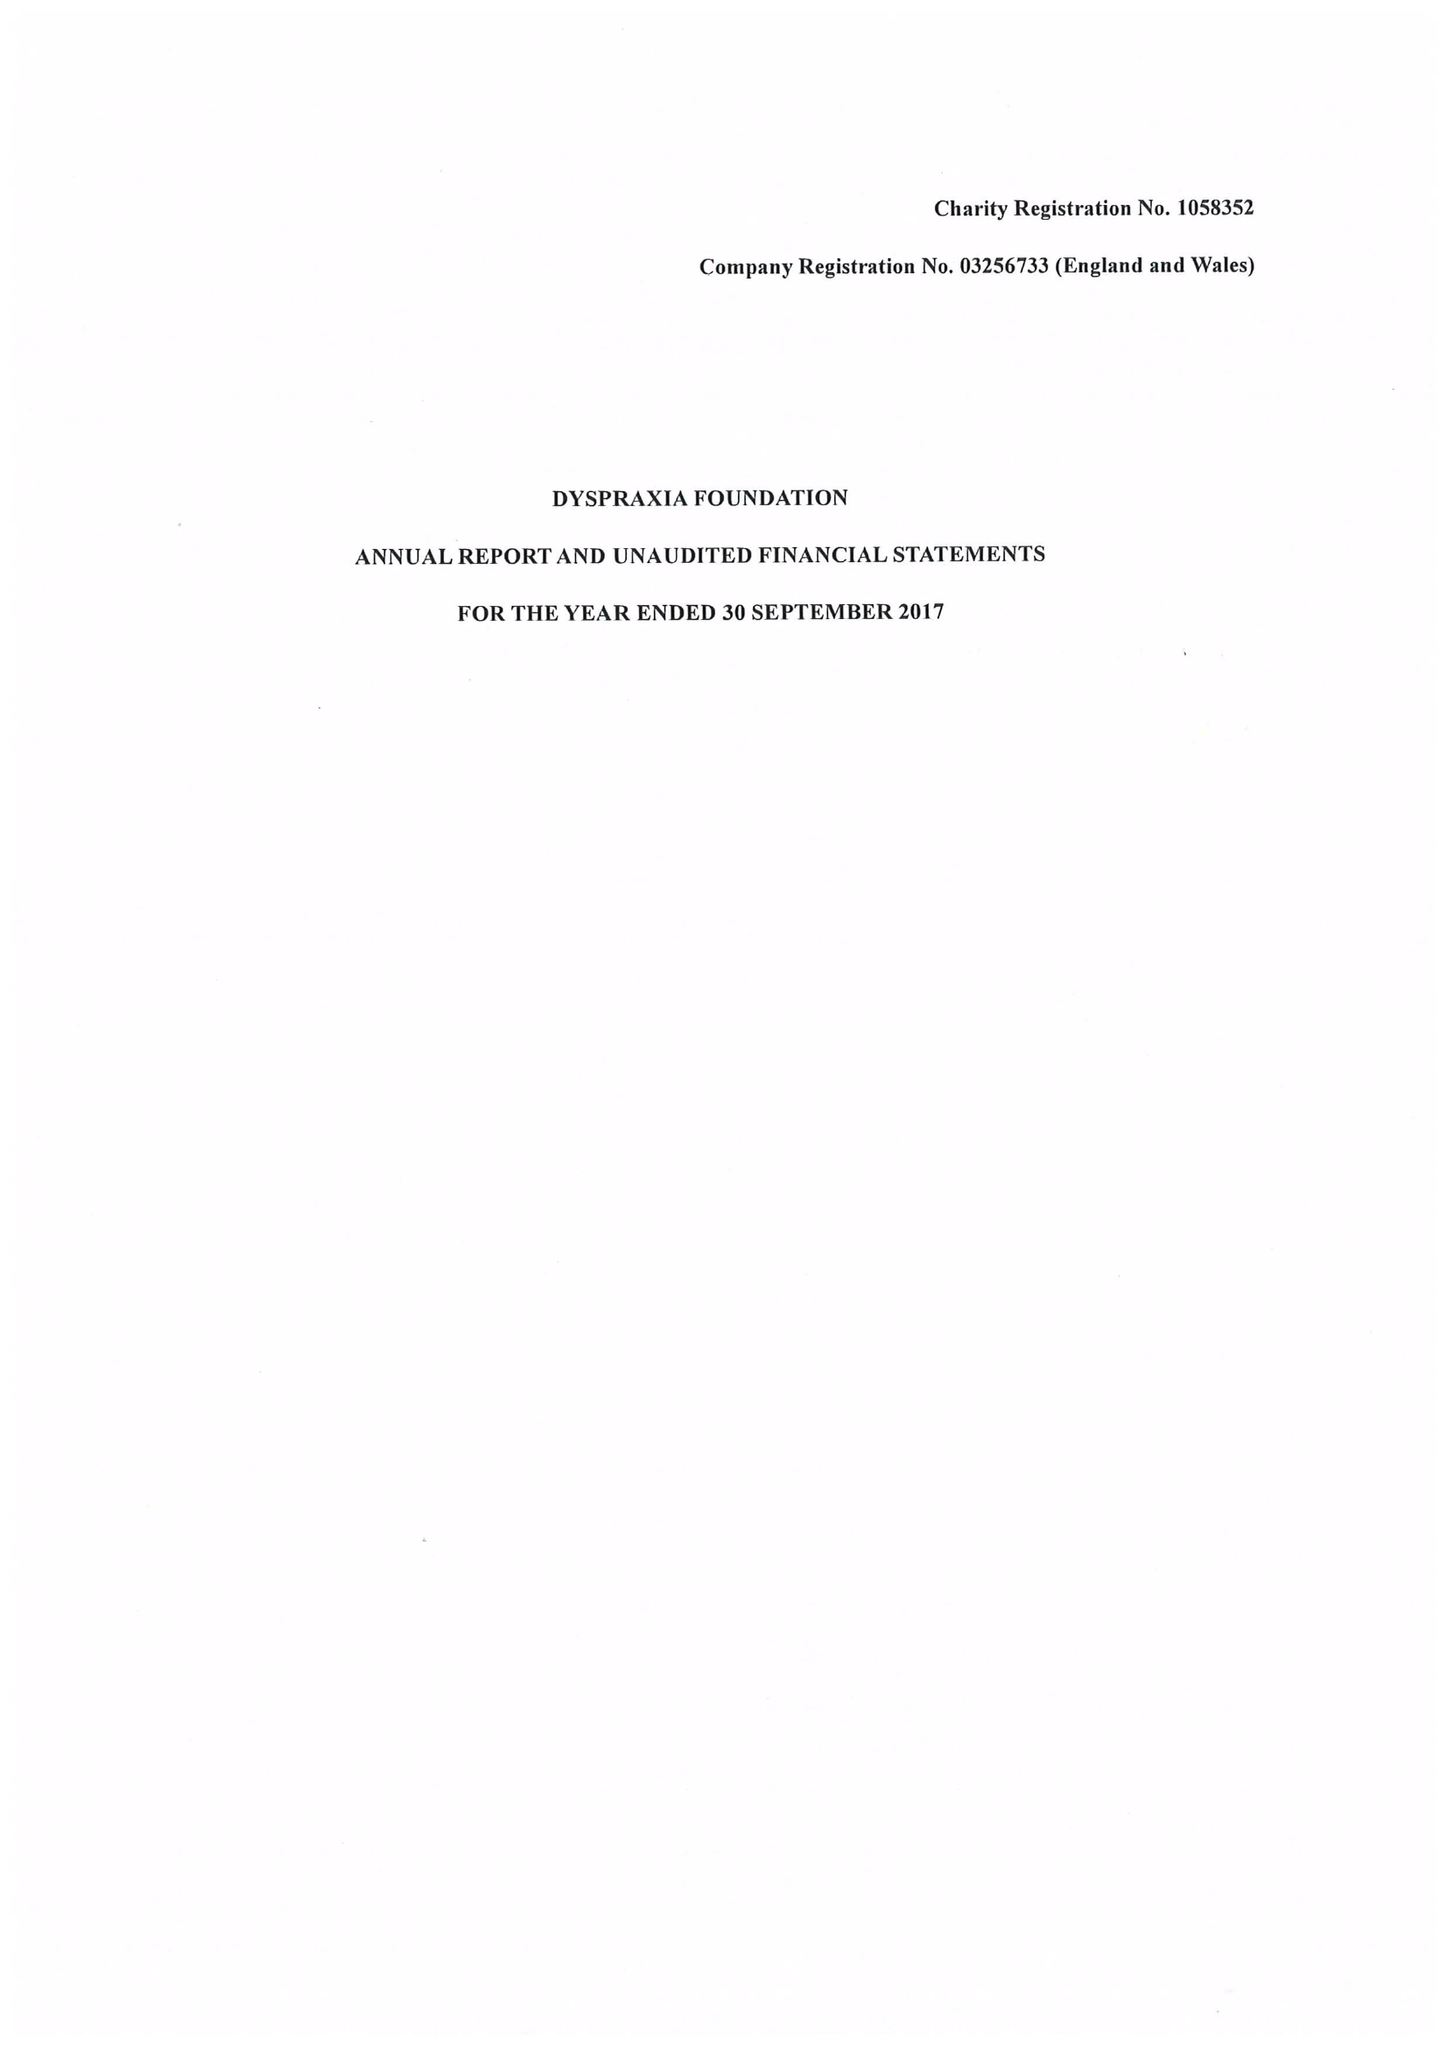What is the value for the spending_annually_in_british_pounds?
Answer the question using a single word or phrase. 174671.00 